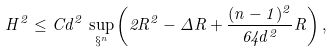<formula> <loc_0><loc_0><loc_500><loc_500>H ^ { 2 } \leq C d ^ { 2 } \, \sup _ { \S ^ { n } } \left ( 2 R ^ { 2 } - \Delta R + \frac { ( n - 1 ) ^ { 2 } } { 6 4 d ^ { 2 } } R \right ) ,</formula> 